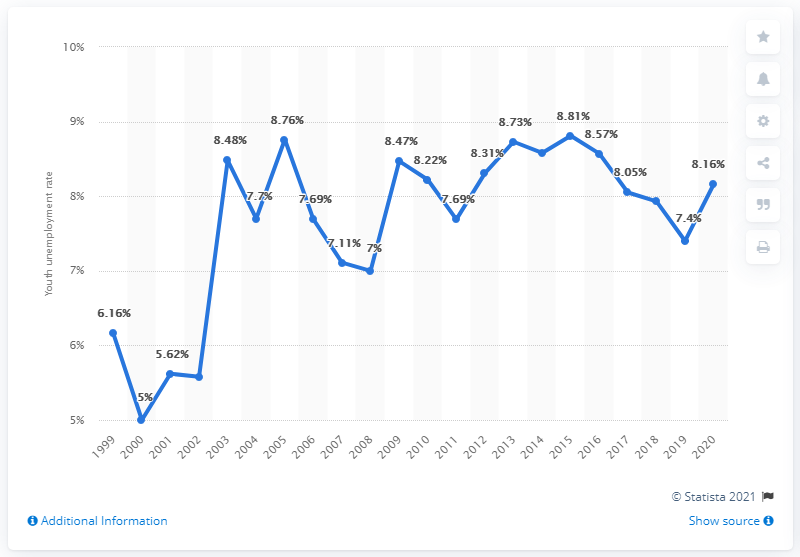Specify some key components in this picture. In 2020, the youth unemployment rate in Switzerland was 8.16%. 